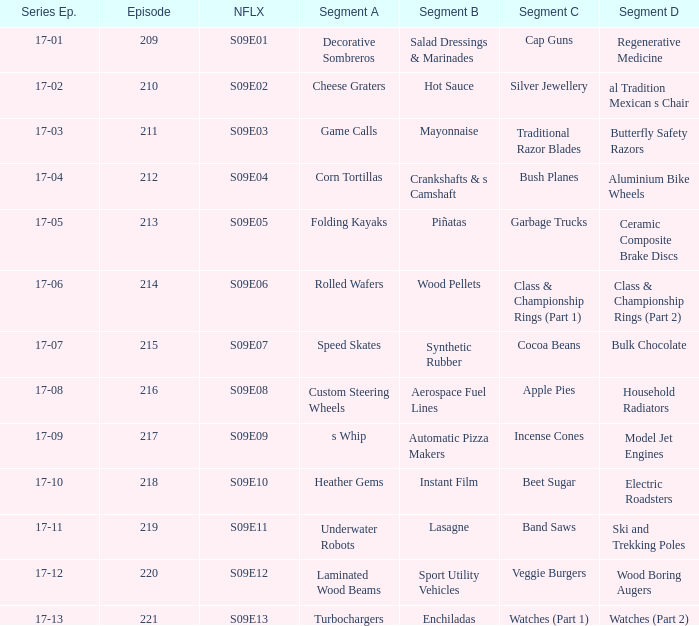Segment B of aerospace fuel lines is what netflix episode? S09E08. 